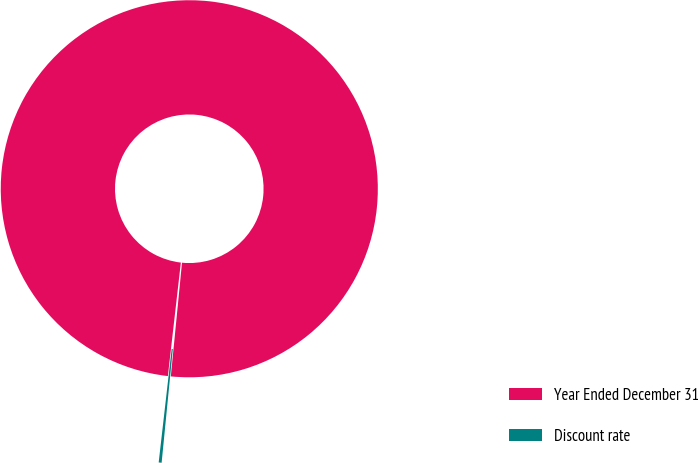Convert chart to OTSL. <chart><loc_0><loc_0><loc_500><loc_500><pie_chart><fcel>Year Ended December 31<fcel>Discount rate<nl><fcel>99.75%<fcel>0.25%<nl></chart> 